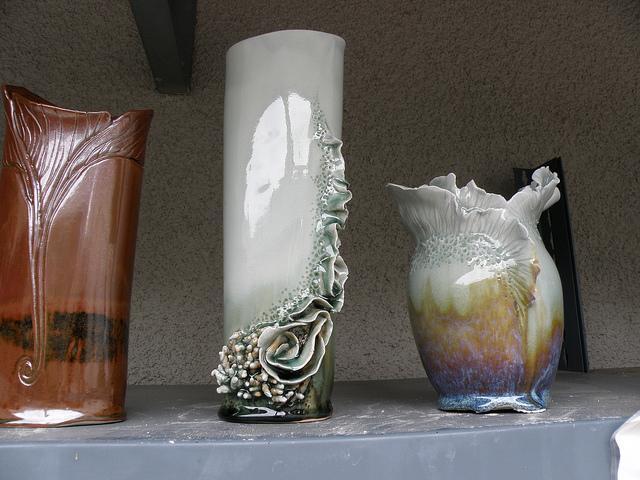How many objects are in the picture?
Give a very brief answer. 3. How many vases are in the photo?
Give a very brief answer. 3. How many trains are there?
Give a very brief answer. 0. 